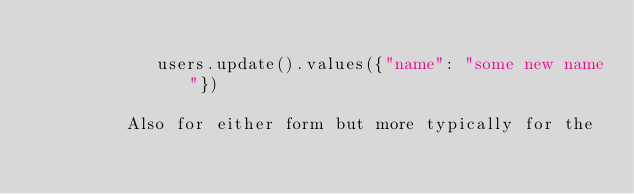Convert code to text. <code><loc_0><loc_0><loc_500><loc_500><_Python_>
            users.update().values({"name": "some new name"})

         Also for either form but more typically for the</code> 